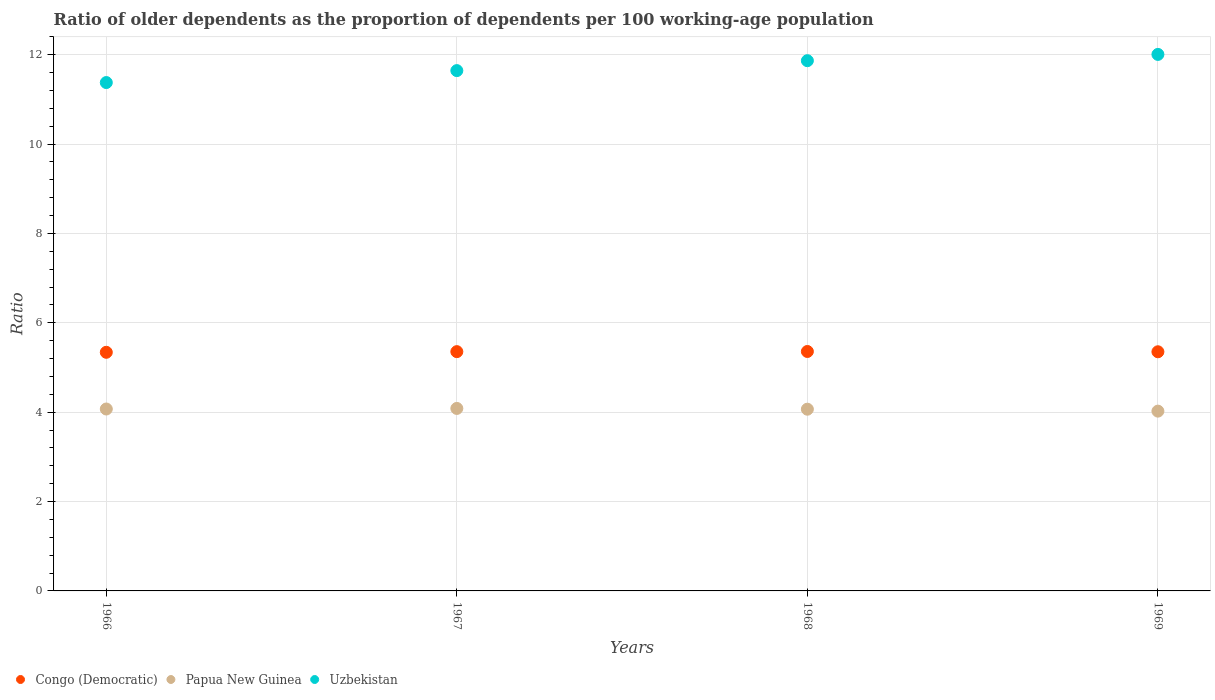How many different coloured dotlines are there?
Your answer should be compact. 3. What is the age dependency ratio(old) in Papua New Guinea in 1967?
Offer a very short reply. 4.08. Across all years, what is the maximum age dependency ratio(old) in Congo (Democratic)?
Offer a terse response. 5.36. Across all years, what is the minimum age dependency ratio(old) in Congo (Democratic)?
Ensure brevity in your answer.  5.34. In which year was the age dependency ratio(old) in Uzbekistan maximum?
Your answer should be compact. 1969. In which year was the age dependency ratio(old) in Uzbekistan minimum?
Give a very brief answer. 1966. What is the total age dependency ratio(old) in Congo (Democratic) in the graph?
Keep it short and to the point. 21.4. What is the difference between the age dependency ratio(old) in Uzbekistan in 1967 and that in 1969?
Provide a short and direct response. -0.36. What is the difference between the age dependency ratio(old) in Papua New Guinea in 1966 and the age dependency ratio(old) in Congo (Democratic) in 1967?
Give a very brief answer. -1.28. What is the average age dependency ratio(old) in Uzbekistan per year?
Your answer should be very brief. 11.72. In the year 1969, what is the difference between the age dependency ratio(old) in Papua New Guinea and age dependency ratio(old) in Congo (Democratic)?
Offer a terse response. -1.33. In how many years, is the age dependency ratio(old) in Congo (Democratic) greater than 2.8?
Ensure brevity in your answer.  4. What is the ratio of the age dependency ratio(old) in Congo (Democratic) in 1967 to that in 1969?
Give a very brief answer. 1. Is the age dependency ratio(old) in Papua New Guinea in 1967 less than that in 1968?
Keep it short and to the point. No. What is the difference between the highest and the second highest age dependency ratio(old) in Congo (Democratic)?
Offer a very short reply. 0. What is the difference between the highest and the lowest age dependency ratio(old) in Congo (Democratic)?
Offer a very short reply. 0.02. Is the sum of the age dependency ratio(old) in Congo (Democratic) in 1967 and 1969 greater than the maximum age dependency ratio(old) in Papua New Guinea across all years?
Your answer should be very brief. Yes. Is it the case that in every year, the sum of the age dependency ratio(old) in Papua New Guinea and age dependency ratio(old) in Congo (Democratic)  is greater than the age dependency ratio(old) in Uzbekistan?
Your answer should be compact. No. Does the graph contain any zero values?
Your response must be concise. No. How many legend labels are there?
Your answer should be compact. 3. How are the legend labels stacked?
Provide a short and direct response. Horizontal. What is the title of the graph?
Offer a very short reply. Ratio of older dependents as the proportion of dependents per 100 working-age population. Does "Malta" appear as one of the legend labels in the graph?
Offer a terse response. No. What is the label or title of the Y-axis?
Make the answer very short. Ratio. What is the Ratio of Congo (Democratic) in 1966?
Give a very brief answer. 5.34. What is the Ratio in Papua New Guinea in 1966?
Your answer should be very brief. 4.07. What is the Ratio in Uzbekistan in 1966?
Give a very brief answer. 11.37. What is the Ratio in Congo (Democratic) in 1967?
Provide a short and direct response. 5.35. What is the Ratio in Papua New Guinea in 1967?
Your answer should be very brief. 4.08. What is the Ratio of Uzbekistan in 1967?
Keep it short and to the point. 11.64. What is the Ratio in Congo (Democratic) in 1968?
Keep it short and to the point. 5.36. What is the Ratio in Papua New Guinea in 1968?
Provide a succinct answer. 4.07. What is the Ratio in Uzbekistan in 1968?
Give a very brief answer. 11.86. What is the Ratio of Congo (Democratic) in 1969?
Your answer should be very brief. 5.35. What is the Ratio of Papua New Guinea in 1969?
Keep it short and to the point. 4.02. What is the Ratio of Uzbekistan in 1969?
Provide a short and direct response. 12. Across all years, what is the maximum Ratio in Congo (Democratic)?
Your answer should be very brief. 5.36. Across all years, what is the maximum Ratio of Papua New Guinea?
Give a very brief answer. 4.08. Across all years, what is the maximum Ratio of Uzbekistan?
Offer a very short reply. 12. Across all years, what is the minimum Ratio of Congo (Democratic)?
Keep it short and to the point. 5.34. Across all years, what is the minimum Ratio in Papua New Guinea?
Provide a succinct answer. 4.02. Across all years, what is the minimum Ratio in Uzbekistan?
Provide a short and direct response. 11.37. What is the total Ratio of Congo (Democratic) in the graph?
Keep it short and to the point. 21.4. What is the total Ratio in Papua New Guinea in the graph?
Your response must be concise. 16.24. What is the total Ratio of Uzbekistan in the graph?
Provide a succinct answer. 46.89. What is the difference between the Ratio of Congo (Democratic) in 1966 and that in 1967?
Offer a very short reply. -0.01. What is the difference between the Ratio in Papua New Guinea in 1966 and that in 1967?
Offer a terse response. -0.01. What is the difference between the Ratio of Uzbekistan in 1966 and that in 1967?
Make the answer very short. -0.27. What is the difference between the Ratio of Congo (Democratic) in 1966 and that in 1968?
Keep it short and to the point. -0.02. What is the difference between the Ratio in Papua New Guinea in 1966 and that in 1968?
Keep it short and to the point. 0. What is the difference between the Ratio of Uzbekistan in 1966 and that in 1968?
Provide a short and direct response. -0.49. What is the difference between the Ratio in Congo (Democratic) in 1966 and that in 1969?
Give a very brief answer. -0.01. What is the difference between the Ratio in Papua New Guinea in 1966 and that in 1969?
Your answer should be compact. 0.05. What is the difference between the Ratio in Uzbekistan in 1966 and that in 1969?
Your answer should be very brief. -0.63. What is the difference between the Ratio in Congo (Democratic) in 1967 and that in 1968?
Make the answer very short. -0. What is the difference between the Ratio in Papua New Guinea in 1967 and that in 1968?
Your response must be concise. 0.02. What is the difference between the Ratio in Uzbekistan in 1967 and that in 1968?
Make the answer very short. -0.22. What is the difference between the Ratio in Congo (Democratic) in 1967 and that in 1969?
Your answer should be very brief. 0. What is the difference between the Ratio in Papua New Guinea in 1967 and that in 1969?
Offer a terse response. 0.06. What is the difference between the Ratio in Uzbekistan in 1967 and that in 1969?
Your answer should be very brief. -0.36. What is the difference between the Ratio of Congo (Democratic) in 1968 and that in 1969?
Give a very brief answer. 0.01. What is the difference between the Ratio in Papua New Guinea in 1968 and that in 1969?
Your answer should be very brief. 0.04. What is the difference between the Ratio of Uzbekistan in 1968 and that in 1969?
Give a very brief answer. -0.14. What is the difference between the Ratio in Congo (Democratic) in 1966 and the Ratio in Papua New Guinea in 1967?
Make the answer very short. 1.26. What is the difference between the Ratio of Congo (Democratic) in 1966 and the Ratio of Uzbekistan in 1967?
Ensure brevity in your answer.  -6.3. What is the difference between the Ratio in Papua New Guinea in 1966 and the Ratio in Uzbekistan in 1967?
Ensure brevity in your answer.  -7.57. What is the difference between the Ratio of Congo (Democratic) in 1966 and the Ratio of Papua New Guinea in 1968?
Ensure brevity in your answer.  1.27. What is the difference between the Ratio of Congo (Democratic) in 1966 and the Ratio of Uzbekistan in 1968?
Offer a terse response. -6.52. What is the difference between the Ratio in Papua New Guinea in 1966 and the Ratio in Uzbekistan in 1968?
Offer a terse response. -7.79. What is the difference between the Ratio in Congo (Democratic) in 1966 and the Ratio in Papua New Guinea in 1969?
Give a very brief answer. 1.32. What is the difference between the Ratio in Congo (Democratic) in 1966 and the Ratio in Uzbekistan in 1969?
Provide a short and direct response. -6.67. What is the difference between the Ratio in Papua New Guinea in 1966 and the Ratio in Uzbekistan in 1969?
Provide a short and direct response. -7.93. What is the difference between the Ratio of Congo (Democratic) in 1967 and the Ratio of Papua New Guinea in 1968?
Give a very brief answer. 1.29. What is the difference between the Ratio in Congo (Democratic) in 1967 and the Ratio in Uzbekistan in 1968?
Offer a terse response. -6.51. What is the difference between the Ratio of Papua New Guinea in 1967 and the Ratio of Uzbekistan in 1968?
Your answer should be very brief. -7.78. What is the difference between the Ratio in Congo (Democratic) in 1967 and the Ratio in Papua New Guinea in 1969?
Your answer should be very brief. 1.33. What is the difference between the Ratio in Congo (Democratic) in 1967 and the Ratio in Uzbekistan in 1969?
Your answer should be compact. -6.65. What is the difference between the Ratio in Papua New Guinea in 1967 and the Ratio in Uzbekistan in 1969?
Your answer should be very brief. -7.92. What is the difference between the Ratio of Congo (Democratic) in 1968 and the Ratio of Papua New Guinea in 1969?
Offer a very short reply. 1.33. What is the difference between the Ratio of Congo (Democratic) in 1968 and the Ratio of Uzbekistan in 1969?
Give a very brief answer. -6.65. What is the difference between the Ratio in Papua New Guinea in 1968 and the Ratio in Uzbekistan in 1969?
Keep it short and to the point. -7.94. What is the average Ratio of Congo (Democratic) per year?
Make the answer very short. 5.35. What is the average Ratio of Papua New Guinea per year?
Your response must be concise. 4.06. What is the average Ratio in Uzbekistan per year?
Provide a short and direct response. 11.72. In the year 1966, what is the difference between the Ratio of Congo (Democratic) and Ratio of Papua New Guinea?
Provide a short and direct response. 1.27. In the year 1966, what is the difference between the Ratio in Congo (Democratic) and Ratio in Uzbekistan?
Your response must be concise. -6.04. In the year 1966, what is the difference between the Ratio in Papua New Guinea and Ratio in Uzbekistan?
Offer a terse response. -7.3. In the year 1967, what is the difference between the Ratio of Congo (Democratic) and Ratio of Papua New Guinea?
Your answer should be very brief. 1.27. In the year 1967, what is the difference between the Ratio in Congo (Democratic) and Ratio in Uzbekistan?
Offer a terse response. -6.29. In the year 1967, what is the difference between the Ratio in Papua New Guinea and Ratio in Uzbekistan?
Offer a terse response. -7.56. In the year 1968, what is the difference between the Ratio in Congo (Democratic) and Ratio in Papua New Guinea?
Provide a short and direct response. 1.29. In the year 1968, what is the difference between the Ratio of Congo (Democratic) and Ratio of Uzbekistan?
Make the answer very short. -6.51. In the year 1968, what is the difference between the Ratio in Papua New Guinea and Ratio in Uzbekistan?
Your answer should be very brief. -7.8. In the year 1969, what is the difference between the Ratio of Congo (Democratic) and Ratio of Papua New Guinea?
Ensure brevity in your answer.  1.33. In the year 1969, what is the difference between the Ratio of Congo (Democratic) and Ratio of Uzbekistan?
Provide a short and direct response. -6.65. In the year 1969, what is the difference between the Ratio in Papua New Guinea and Ratio in Uzbekistan?
Keep it short and to the point. -7.98. What is the ratio of the Ratio of Congo (Democratic) in 1966 to that in 1967?
Offer a terse response. 1. What is the ratio of the Ratio in Congo (Democratic) in 1966 to that in 1968?
Your answer should be compact. 1. What is the ratio of the Ratio of Papua New Guinea in 1966 to that in 1968?
Your response must be concise. 1. What is the ratio of the Ratio of Uzbekistan in 1966 to that in 1968?
Provide a succinct answer. 0.96. What is the ratio of the Ratio of Papua New Guinea in 1966 to that in 1969?
Offer a terse response. 1.01. What is the ratio of the Ratio of Uzbekistan in 1966 to that in 1969?
Ensure brevity in your answer.  0.95. What is the ratio of the Ratio in Congo (Democratic) in 1967 to that in 1968?
Offer a very short reply. 1. What is the ratio of the Ratio of Uzbekistan in 1967 to that in 1968?
Your answer should be compact. 0.98. What is the ratio of the Ratio of Congo (Democratic) in 1967 to that in 1969?
Provide a short and direct response. 1. What is the ratio of the Ratio in Uzbekistan in 1967 to that in 1969?
Your answer should be very brief. 0.97. What is the ratio of the Ratio of Congo (Democratic) in 1968 to that in 1969?
Provide a succinct answer. 1. What is the ratio of the Ratio in Papua New Guinea in 1968 to that in 1969?
Make the answer very short. 1.01. What is the ratio of the Ratio of Uzbekistan in 1968 to that in 1969?
Your answer should be compact. 0.99. What is the difference between the highest and the second highest Ratio of Congo (Democratic)?
Your answer should be compact. 0. What is the difference between the highest and the second highest Ratio in Papua New Guinea?
Provide a succinct answer. 0.01. What is the difference between the highest and the second highest Ratio of Uzbekistan?
Keep it short and to the point. 0.14. What is the difference between the highest and the lowest Ratio of Congo (Democratic)?
Give a very brief answer. 0.02. What is the difference between the highest and the lowest Ratio in Papua New Guinea?
Provide a succinct answer. 0.06. What is the difference between the highest and the lowest Ratio in Uzbekistan?
Provide a succinct answer. 0.63. 